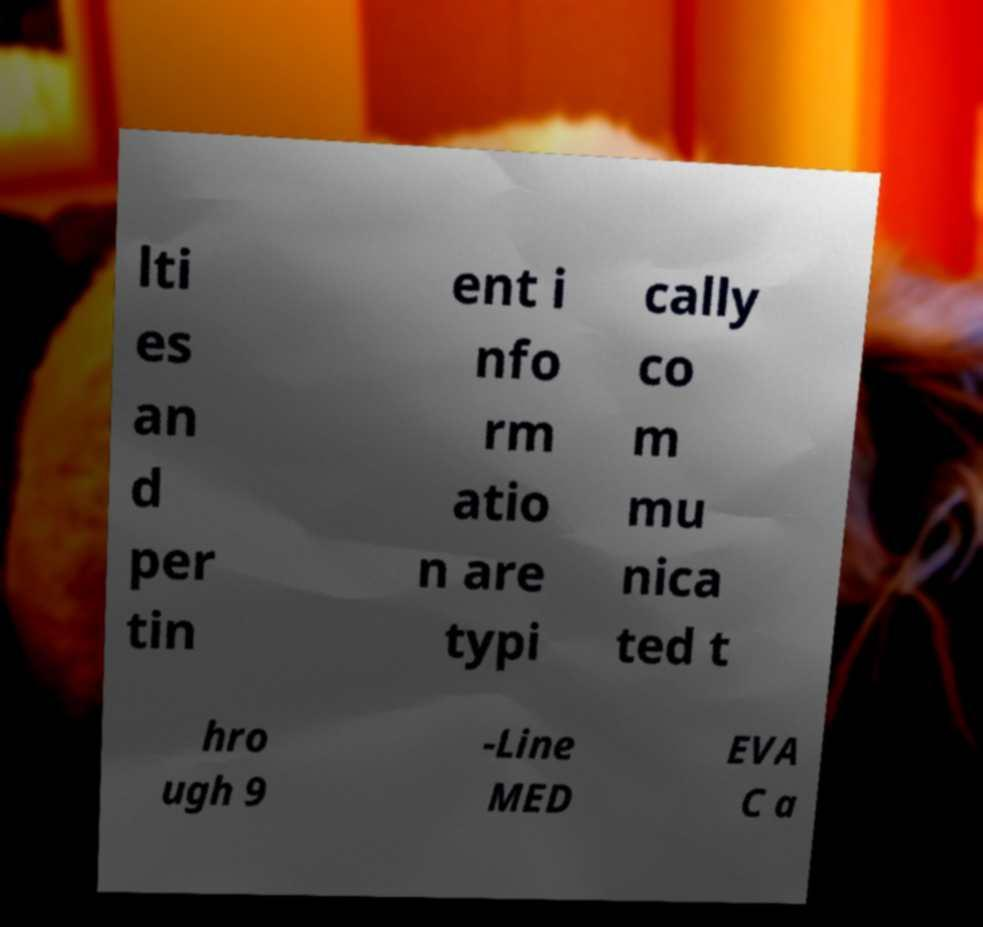For documentation purposes, I need the text within this image transcribed. Could you provide that? lti es an d per tin ent i nfo rm atio n are typi cally co m mu nica ted t hro ugh 9 -Line MED EVA C a 